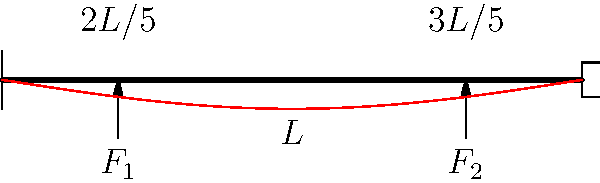As a seasoned policy maker, you understand the importance of stress analysis in infrastructure projects. Consider a simply supported beam of length $L$ subjected to two point loads $F_1$ and $F_2$ at distances $2L/5$ and $3L/5$ from the left support, respectively. Given that the maximum bending stress in the beam is $\sigma_{max} = 120$ MPa, and the cross-section is rectangular with a width-to-height ratio of 1:2, determine the required height of the beam in terms of $F_1$, $F_2$, and $L$. Let's approach this step-by-step:

1) The maximum bending moment occurs at the point of application of one of the loads. We need to calculate reactions and moments to determine which load causes the maximum moment.

2) For equilibrium of forces: 
   $R_A + R_B = F_1 + F_2$
   where $R_A$ and $R_B$ are reaction forces at the supports.

3) Taking moments about A:
   $R_B L = F_1 (2L/5) + F_2 (3L/5)$
   $R_B = F_1 (2/5) + F_2 (3/5)$

4) The bending moment at the point of application of $F_1$ is:
   $M_1 = R_A (2L/5) = (R_B - F_2) (2L/5)$

5) The bending moment at the point of application of $F_2$ is:
   $M_2 = R_A (3L/5) - F_1 (L/5) = (R_B - F_2) (3L/5) - F_1 (L/5)$

6) The maximum of these two will be the maximum bending moment, $M_{max}$.

7) The bending stress formula is:
   $\sigma = \frac{My}{I}$
   where $M$ is the bending moment, $y$ is the distance from the neutral axis to the extreme fiber, and $I$ is the moment of inertia.

8) For a rectangular cross-section with width $b$ and height $h$:
   $I = \frac{bh^3}{12}$ and $y = h/2$

9) Given that $b = h/2$, we can substitute these into the stress formula:
   $\sigma_{max} = \frac{M_{max}(h/2)}{(h/2)(h^3/12)} = \frac{6M_{max}}{h^3}$

10) Rearranging for $h$:
    $h = \sqrt[3]{\frac{6M_{max}}{\sigma_{max}}}$

11) Substituting the given value of $\sigma_{max} = 120$ MPa:
    $h = \sqrt[3]{\frac{6M_{max}}{120 \times 10^6}}$

12) $M_{max}$ will be a function of $F_1$, $F_2$, and $L$, so our final answer will be in terms of these variables.
Answer: $h = \sqrt[3]{\frac{6M_{max}}{120 \times 10^6}}$, where $M_{max} = \max[(R_B - F_2)(2L/5), (R_B - F_2)(3L/5) - F_1(L/5)]$ and $R_B = F_1(2/5) + F_2(3/5)$ 